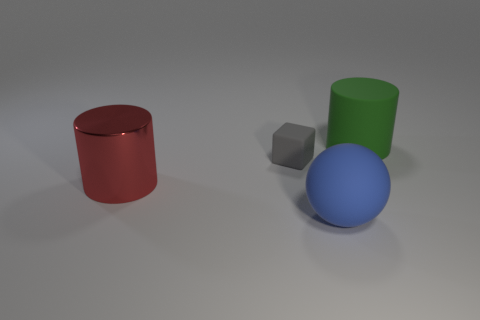Add 2 blocks. How many objects exist? 6 Subtract all green cylinders. How many cylinders are left? 1 Subtract all blocks. How many objects are left? 3 Add 3 large things. How many large things are left? 6 Add 2 blue matte balls. How many blue matte balls exist? 3 Subtract 0 gray balls. How many objects are left? 4 Subtract all brown cylinders. Subtract all yellow blocks. How many cylinders are left? 2 Subtract all tiny things. Subtract all red shiny cylinders. How many objects are left? 2 